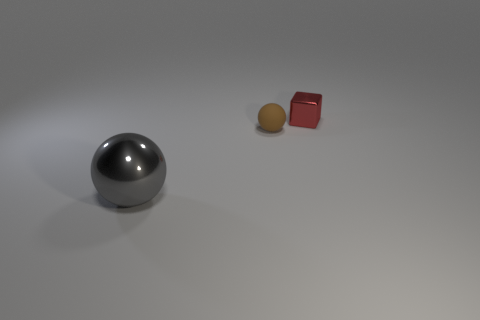Add 3 gray metal spheres. How many objects exist? 6 Subtract all blocks. How many objects are left? 2 Subtract all large green blocks. Subtract all gray spheres. How many objects are left? 2 Add 3 shiny things. How many shiny things are left? 5 Add 1 large gray spheres. How many large gray spheres exist? 2 Subtract 0 gray blocks. How many objects are left? 3 